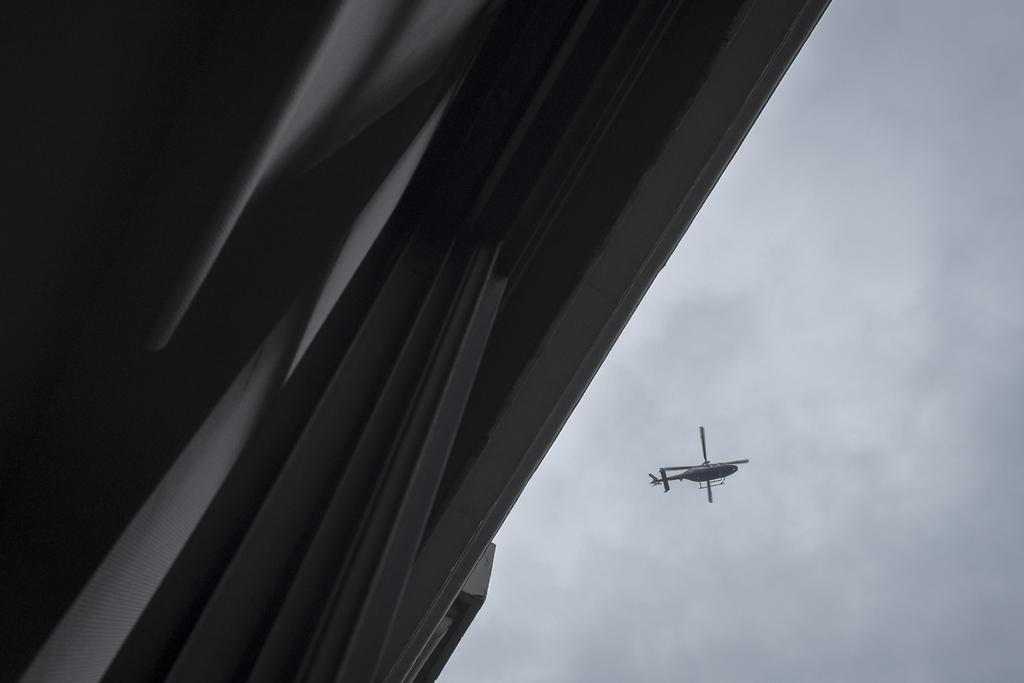What is the main subject of the image? The main subject of the image is an helicopter. What is the helicopter doing in the image? The helicopter is flying in the sky. From where was the image captured? The image is captured from the ground. What can be seen in the background of the helicopter? The sky is visible in the background of the helicopter. How would you describe the sky in the image? The sky appears to be dark. What type of hammer is being used to prepare a meal in the image? There is no hammer or meal preparation visible in the image; it features an helicopter flying in the sky. Is there any grass visible in the image? There is no grass visible in the image; it only shows an helicopter flying in the sky. 